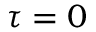Convert formula to latex. <formula><loc_0><loc_0><loc_500><loc_500>\tau = 0</formula> 